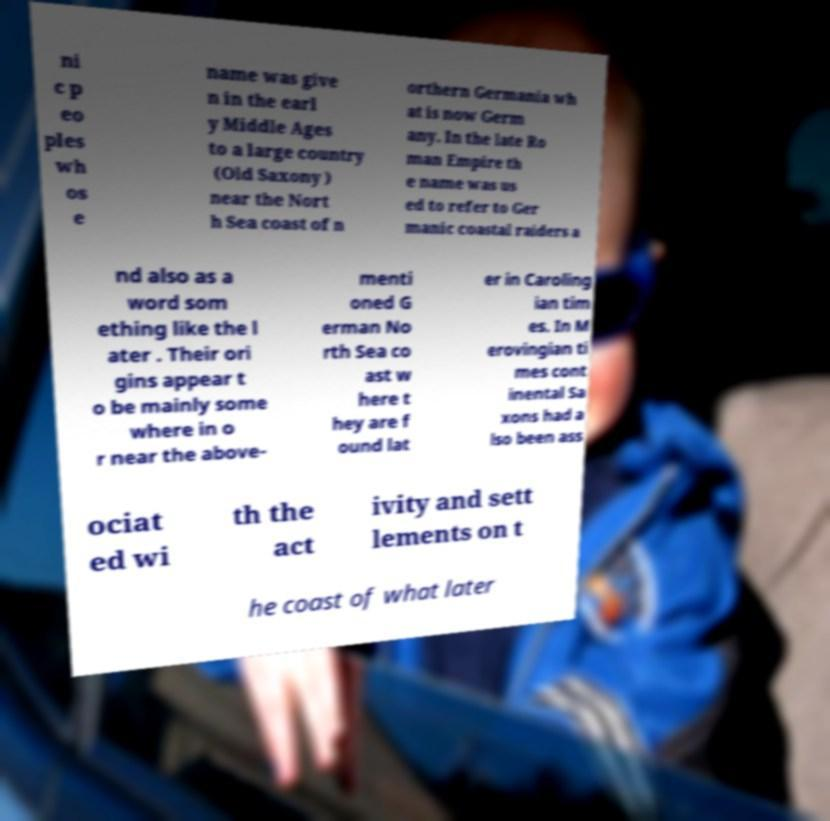I need the written content from this picture converted into text. Can you do that? ni c p eo ples wh os e name was give n in the earl y Middle Ages to a large country (Old Saxony ) near the Nort h Sea coast of n orthern Germania wh at is now Germ any. In the late Ro man Empire th e name was us ed to refer to Ger manic coastal raiders a nd also as a word som ething like the l ater . Their ori gins appear t o be mainly some where in o r near the above- menti oned G erman No rth Sea co ast w here t hey are f ound lat er in Caroling ian tim es. In M erovingian ti mes cont inental Sa xons had a lso been ass ociat ed wi th the act ivity and sett lements on t he coast of what later 